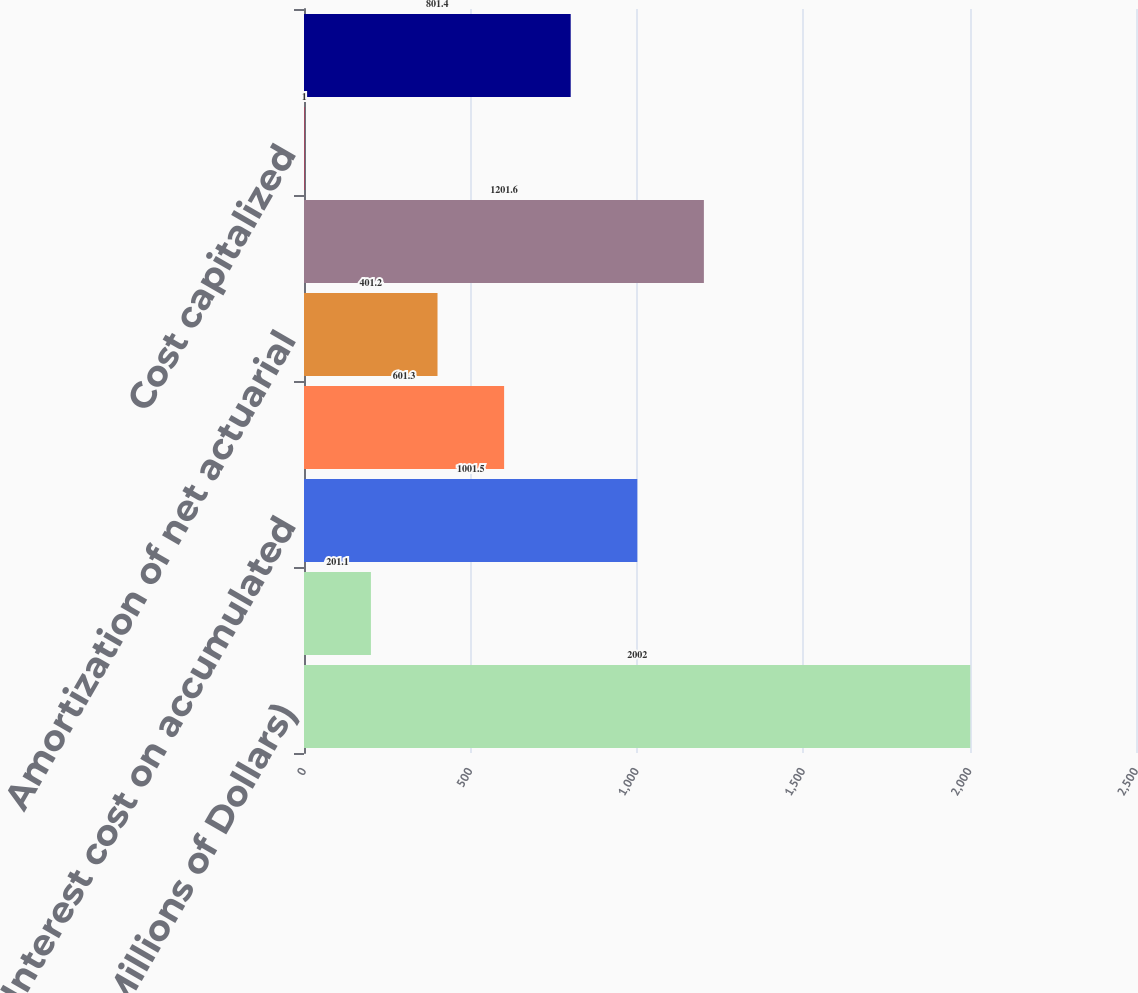Convert chart to OTSL. <chart><loc_0><loc_0><loc_500><loc_500><bar_chart><fcel>(Millions of Dollars)<fcel>Service cost<fcel>Interest cost on accumulated<fcel>Expected return on plan assets<fcel>Amortization of net actuarial<fcel>Net Periodic Postretirement<fcel>Cost capitalized<fcel>Cost charged to operating<nl><fcel>2002<fcel>201.1<fcel>1001.5<fcel>601.3<fcel>401.2<fcel>1201.6<fcel>1<fcel>801.4<nl></chart> 